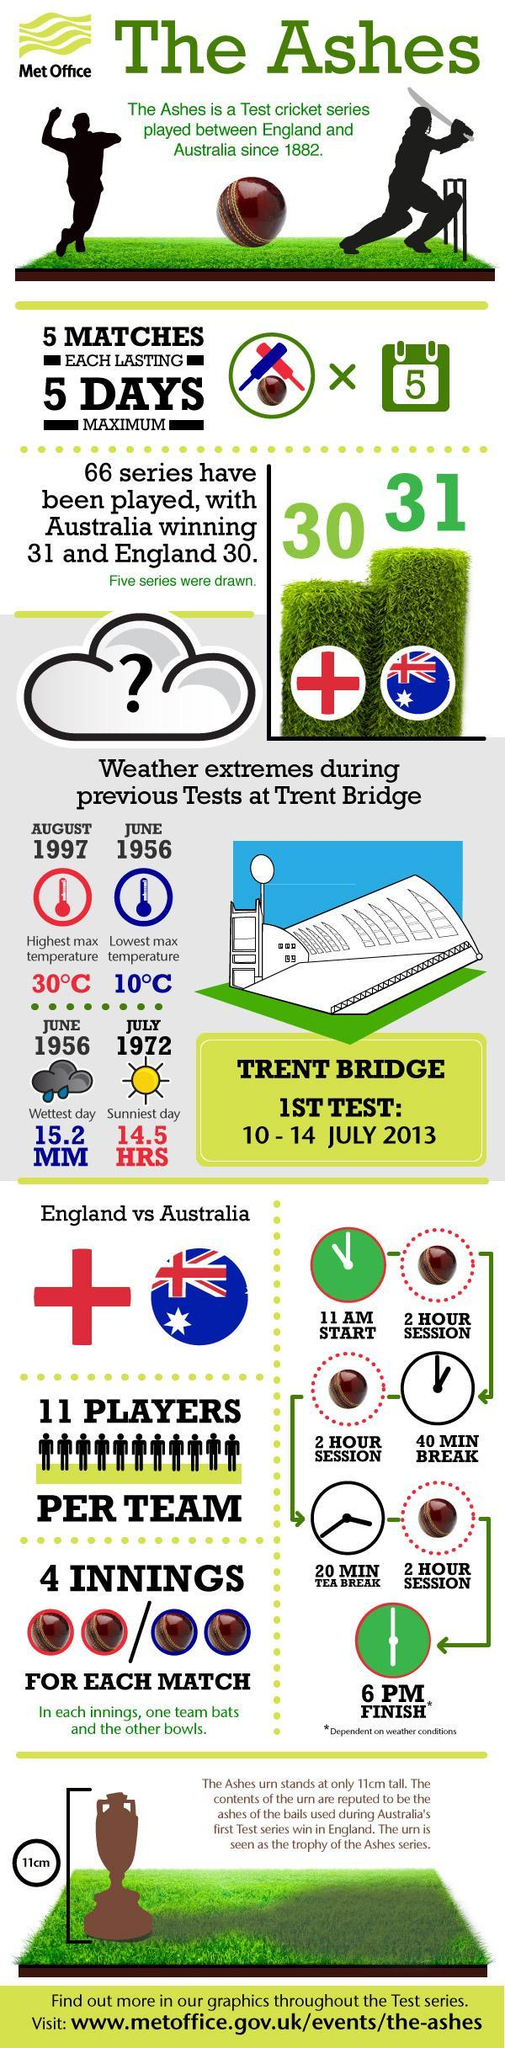In a test match, how many innings do each team bat
Answer the question with a short phrase. 2 How many maximum days will it take for 5 matches each lasting 5 days maximum 25 WHo has a higher score in The Ashes series Australia Where was the weather recorded Trent Bridge In a test match, how many innings do each team bowl 2 For how many days maximum is a test match 5 Which month and year was the highest temperature recorded August 1997 